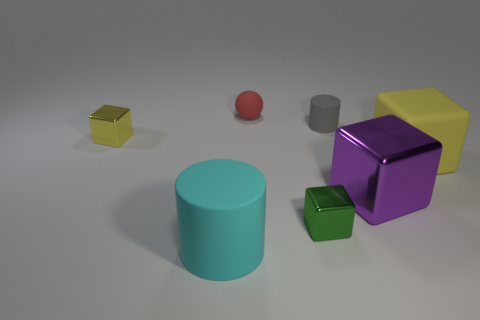The small metal object that is the same color as the matte cube is what shape?
Your response must be concise. Cube. The yellow thing that is the same size as the purple shiny object is what shape?
Keep it short and to the point. Cube. Do the yellow rubber object and the large shiny thing have the same shape?
Ensure brevity in your answer.  Yes. How many other tiny things are the same shape as the cyan object?
Keep it short and to the point. 1. There is a tiny sphere; what number of matte things are on the right side of it?
Provide a succinct answer. 2. There is a tiny block to the left of the red rubber sphere; does it have the same color as the large rubber cube?
Provide a short and direct response. Yes. How many other rubber things have the same size as the yellow rubber object?
Provide a short and direct response. 1. There is a big cyan object that is the same material as the tiny cylinder; what is its shape?
Your answer should be compact. Cylinder. Are there any objects of the same color as the big matte cube?
Your answer should be compact. Yes. What is the large yellow block made of?
Offer a terse response. Rubber. 